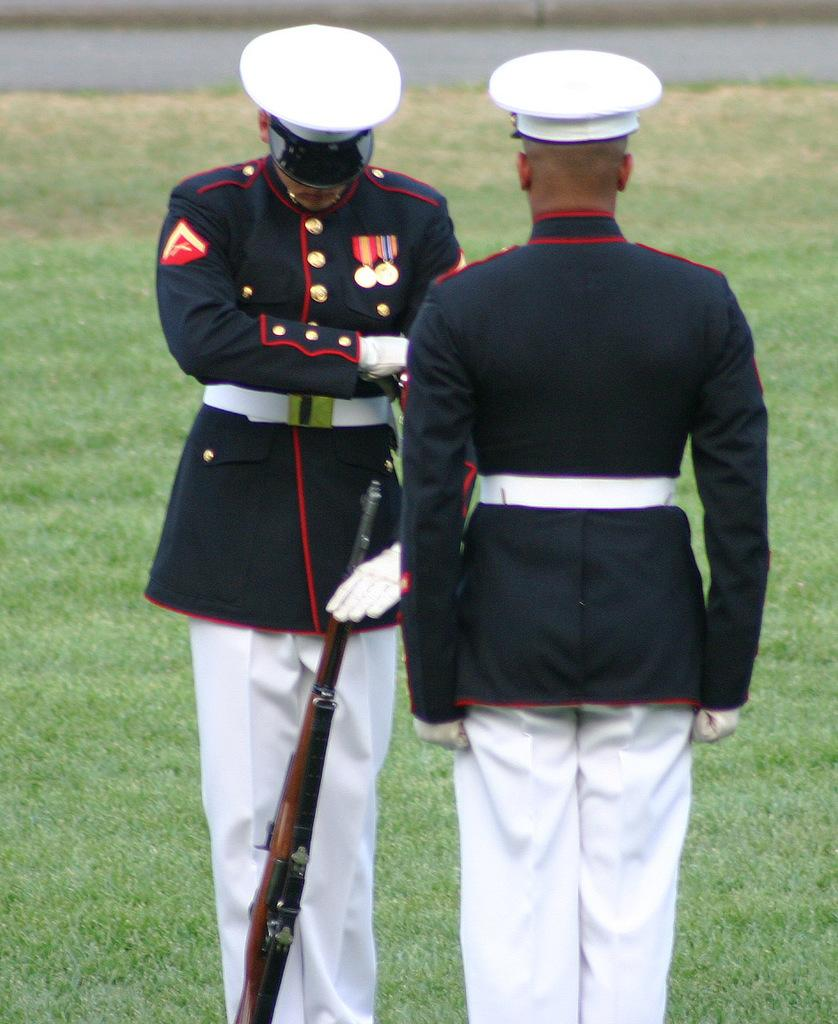How many men are in the image? There are two men in the image. What are the men wearing? The men are wearing uniforms and white color hats. What is the man on the left side holding? The man on the left side is holding a gun. What can be seen in the background of the image? There is grass visible in the background of the image. How many chickens are present in the image? There are no chickens present in the image. What type of headwear is the man on the right side wearing? The men in the image are both wearing white color hats, so there is no need to specify the headwear for the man on the right side. 